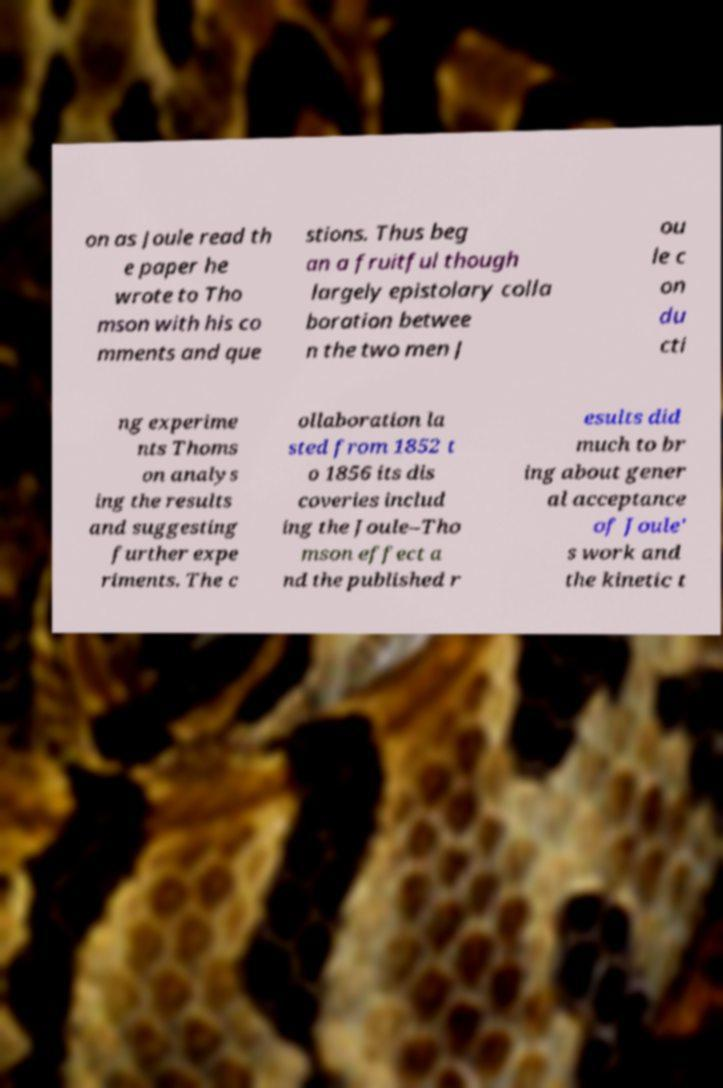Can you accurately transcribe the text from the provided image for me? on as Joule read th e paper he wrote to Tho mson with his co mments and que stions. Thus beg an a fruitful though largely epistolary colla boration betwee n the two men J ou le c on du cti ng experime nts Thoms on analys ing the results and suggesting further expe riments. The c ollaboration la sted from 1852 t o 1856 its dis coveries includ ing the Joule–Tho mson effect a nd the published r esults did much to br ing about gener al acceptance of Joule' s work and the kinetic t 